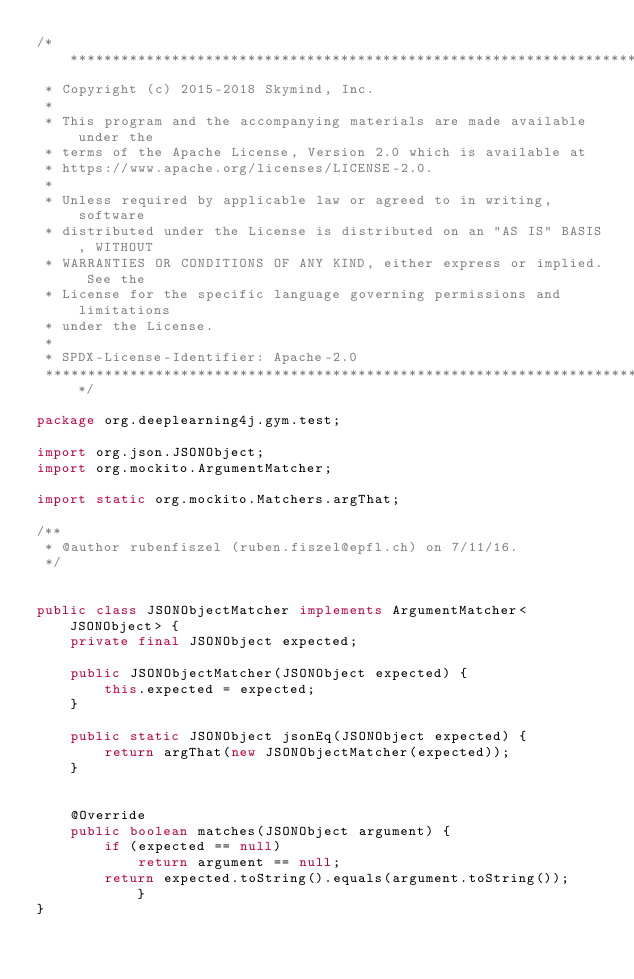<code> <loc_0><loc_0><loc_500><loc_500><_Java_>/*******************************************************************************
 * Copyright (c) 2015-2018 Skymind, Inc.
 *
 * This program and the accompanying materials are made available under the
 * terms of the Apache License, Version 2.0 which is available at
 * https://www.apache.org/licenses/LICENSE-2.0.
 *
 * Unless required by applicable law or agreed to in writing, software
 * distributed under the License is distributed on an "AS IS" BASIS, WITHOUT
 * WARRANTIES OR CONDITIONS OF ANY KIND, either express or implied. See the
 * License for the specific language governing permissions and limitations
 * under the License.
 *
 * SPDX-License-Identifier: Apache-2.0
 ******************************************************************************/

package org.deeplearning4j.gym.test;

import org.json.JSONObject;
import org.mockito.ArgumentMatcher;

import static org.mockito.Matchers.argThat;

/**
 * @author rubenfiszel (ruben.fiszel@epfl.ch) on 7/11/16.
 */


public class JSONObjectMatcher implements ArgumentMatcher<JSONObject> {
    private final JSONObject expected;

    public JSONObjectMatcher(JSONObject expected) {
        this.expected = expected;
    }

    public static JSONObject jsonEq(JSONObject expected) {
        return argThat(new JSONObjectMatcher(expected));
    }


    @Override
    public boolean matches(JSONObject argument) {
        if (expected == null)
            return argument == null;
        return expected.toString().equals(argument.toString());    }
}
</code> 